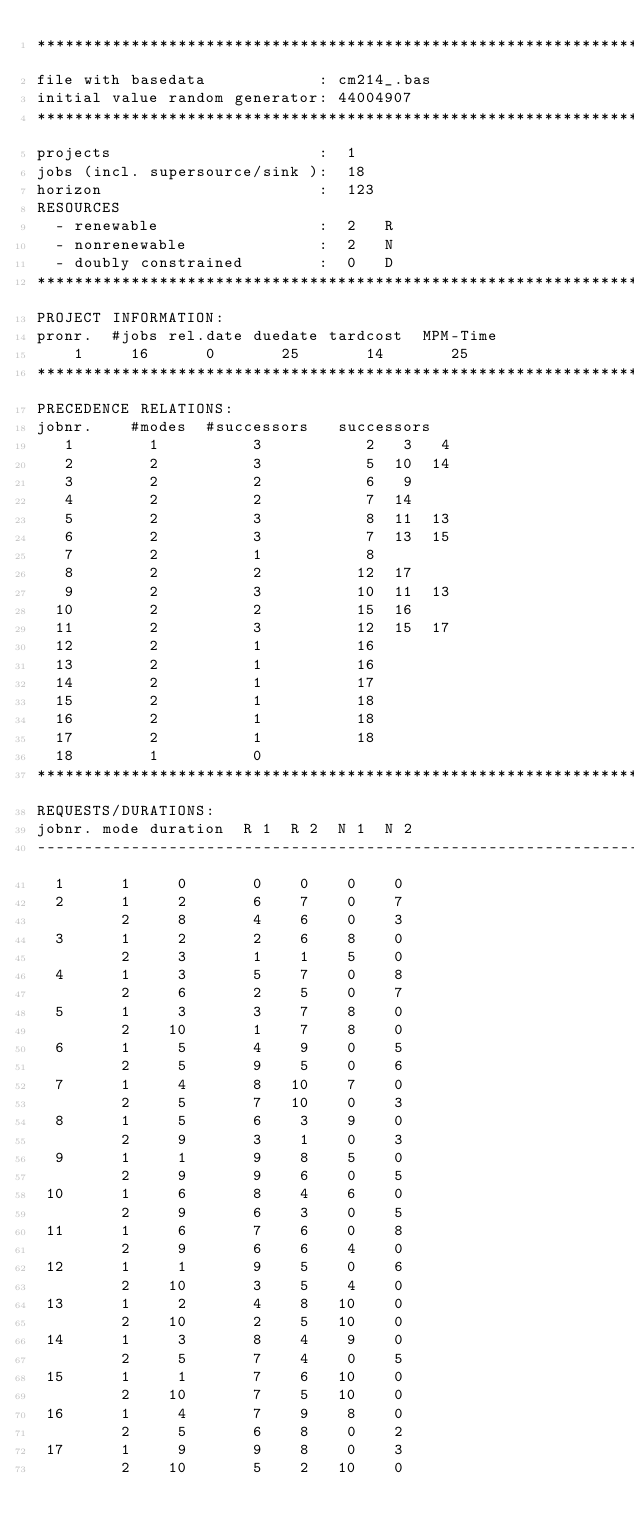Convert code to text. <code><loc_0><loc_0><loc_500><loc_500><_ObjectiveC_>************************************************************************
file with basedata            : cm214_.bas
initial value random generator: 44004907
************************************************************************
projects                      :  1
jobs (incl. supersource/sink ):  18
horizon                       :  123
RESOURCES
  - renewable                 :  2   R
  - nonrenewable              :  2   N
  - doubly constrained        :  0   D
************************************************************************
PROJECT INFORMATION:
pronr.  #jobs rel.date duedate tardcost  MPM-Time
    1     16      0       25       14       25
************************************************************************
PRECEDENCE RELATIONS:
jobnr.    #modes  #successors   successors
   1        1          3           2   3   4
   2        2          3           5  10  14
   3        2          2           6   9
   4        2          2           7  14
   5        2          3           8  11  13
   6        2          3           7  13  15
   7        2          1           8
   8        2          2          12  17
   9        2          3          10  11  13
  10        2          2          15  16
  11        2          3          12  15  17
  12        2          1          16
  13        2          1          16
  14        2          1          17
  15        2          1          18
  16        2          1          18
  17        2          1          18
  18        1          0        
************************************************************************
REQUESTS/DURATIONS:
jobnr. mode duration  R 1  R 2  N 1  N 2
------------------------------------------------------------------------
  1      1     0       0    0    0    0
  2      1     2       6    7    0    7
         2     8       4    6    0    3
  3      1     2       2    6    8    0
         2     3       1    1    5    0
  4      1     3       5    7    0    8
         2     6       2    5    0    7
  5      1     3       3    7    8    0
         2    10       1    7    8    0
  6      1     5       4    9    0    5
         2     5       9    5    0    6
  7      1     4       8   10    7    0
         2     5       7   10    0    3
  8      1     5       6    3    9    0
         2     9       3    1    0    3
  9      1     1       9    8    5    0
         2     9       9    6    0    5
 10      1     6       8    4    6    0
         2     9       6    3    0    5
 11      1     6       7    6    0    8
         2     9       6    6    4    0
 12      1     1       9    5    0    6
         2    10       3    5    4    0
 13      1     2       4    8   10    0
         2    10       2    5   10    0
 14      1     3       8    4    9    0
         2     5       7    4    0    5
 15      1     1       7    6   10    0
         2    10       7    5   10    0
 16      1     4       7    9    8    0
         2     5       6    8    0    2
 17      1     9       9    8    0    3
         2    10       5    2   10    0</code> 